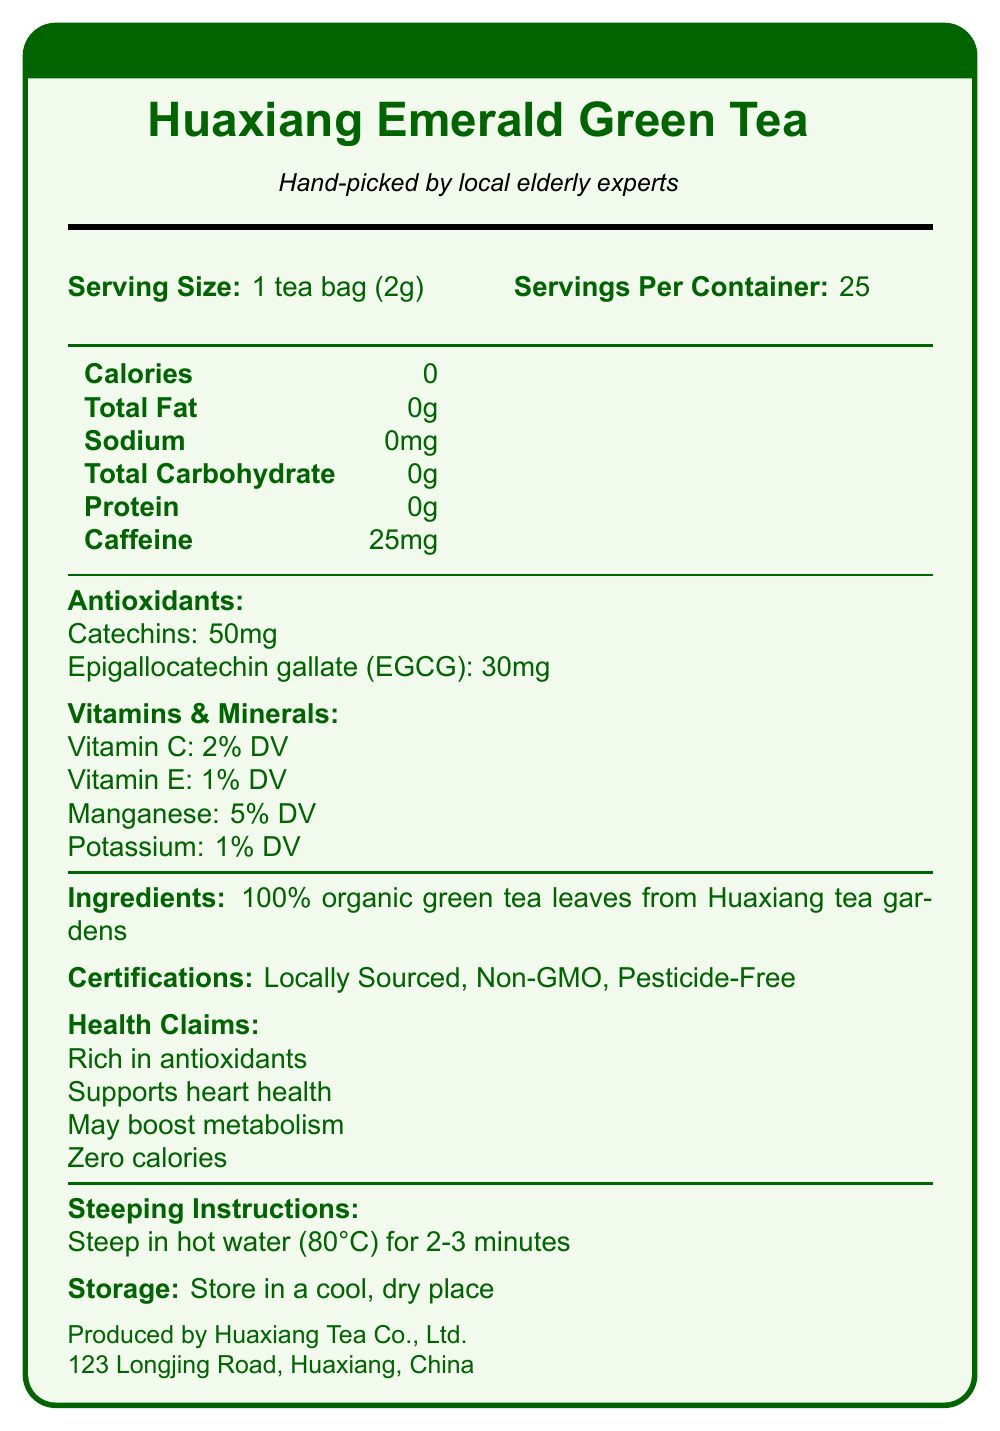what is the calorie content per serving? The document states "Calories: 0" under the nutrition information.
Answer: 0 calories how many servings are in one container? The document lists "Servings Per Container: 25."
Answer: 25 servings what type of antioxidants are present in the Huaxiang Emerald Green Tea? The document specifies "Catechins: 50mg" and "Epigallocatechin gallate (EGCG): 30mg" under the antioxidants section.
Answer: Catechins and Epigallocatechin gallate (EGCG) what certifications does this green tea have? The document lists these certifications under the certifications section.
Answer: Locally Sourced, Non-GMO, Pesticide-Free how much caffeine is in one serving of this green tea? The document mentions "Caffeine: 25mg" in the nutrition information.
Answer: 25mg what percentage of daily value of manganese does this green tea provide? The document lists "Manganese: 5% DV" under the vitamins and minerals section.
Answer: 5% DV where is the Huaxiang Emerald Green Tea produced? The document provides this information at the bottom under the manufacturer info section.
Answer: Huaxiang Tea Co., Ltd., 123 Longjing Road, Huaxiang, China how should the green tea be steeped? The document lists these instructions under the steeping instructions section.
Answer: Steep in hot water (80°C) for 2-3 minutes including Triple Antioxidants, The document does not mention a term or phrase like "Triple Antioxidants."
Answer: Not enough information what is the serving size? A. 1 cup (240 ml) B. 1 tea bag (2g) C. 2 tea bags (4g) The document states "Serving Size: 1 tea bag (2g)."
Answer: B which vitamin is present in the lowest percentage of daily value? A. Vitamin C B. Vitamin E C. Manganese D. Potassium The document states "Vitamin E: 1% DV," which is the lowest compared to others listed.
Answer: B does the green tea contain any carbohydrates? The document states "Total Carbohydrate: 0g."
Answer: No summarize the main data provided in this document The document encompasses detailed nutritional facts of green tea, antioxidant properties, certification, and manufacturer information.
Answer: This document provides detailed nutritional information about Huaxiang Emerald Green Tea. It lists zero calories per serving, various antioxidants including catechins and EGCG, vitamins and minerals such as vitamin C, vitamin E, manganese, and potassium. It also highlights its caffeine content and provides steeping and storage instructions. The tea is certified as locally sourced, non-GMO, and pesticide-free. what is the recommended steeping temperature for the tea? The document states under the steeping instructions, "Steep in hot water (80°C) for 2-3 minutes."
Answer: 80°C 